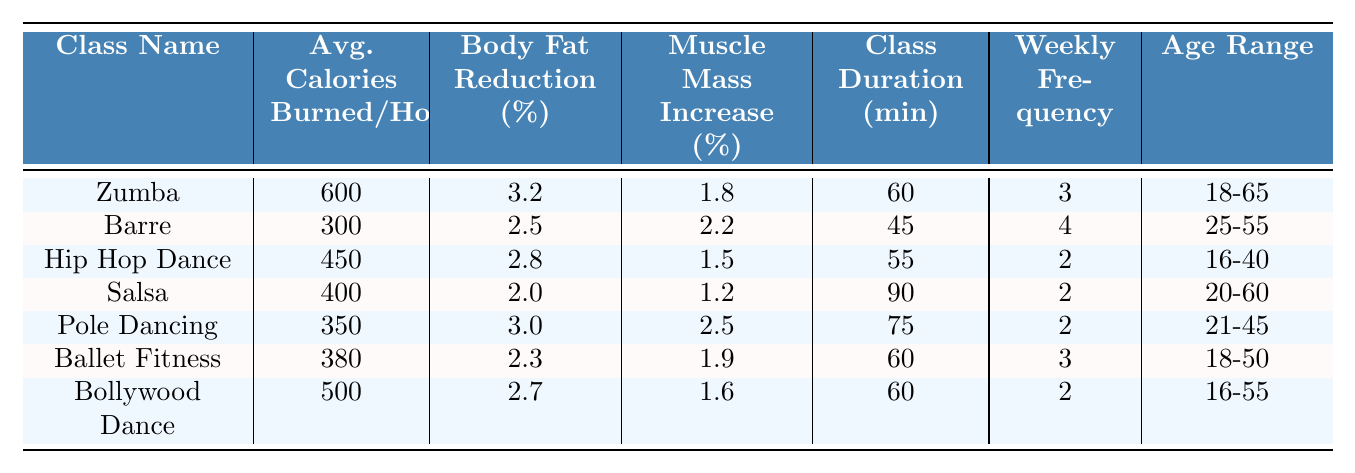What is the average number of calories burned per hour in Zumba classes? The table lists the average calories burned per hour for Zumba as 600.
Answer: 600 How many minutes does a Barre class typically last? The table shows that the class duration for Barre is 45 minutes.
Answer: 45 Which dance fitness class has the highest body fat reduction percentage? According to the table, Zumba has the highest body fat reduction percentage at 3.2%.
Answer: Zumba What is the weekly frequency of Ballet Fitness classes? The weekly frequency for Ballet Fitness is stated as 3 in the table.
Answer: 3 Which class has the least average calories burned per hour? By comparing the values in the table, Barre has the least calories burned per hour at 300.
Answer: Barre What is the difference in body fat reduction percentage between Zumba and Pole Dancing? Zumba has a body fat reduction percentage of 3.2% and Pole Dancing has 3.0%. The difference is 3.2 - 3.0 = 0.2.
Answer: 0.2 If someone attends Hip Hop Dance classes, how many calories would they burn in four classes? Hip Hop Dance burns 450 calories per hour and the class duration is 55 minutes. In four classes, they would burn approximately (450/60*55*4) = 990 calories.
Answer: 990 Is the average muscle mass increase percentage higher in Barre than in Ballet Fitness? Barre's muscle mass increase percentage is 2.2%, and Ballet Fitness is 1.9%. Since 2.2% is greater than 1.9%, the statement is true.
Answer: Yes How many total minutes would a participant spend in a week attending Salsa classes? Salsa classes last 90 minutes and are attended twice a week, so the total duration is 90 * 2 = 180 minutes.
Answer: 180 Which class has the highest muscle mass increase percentage and what is that percentage? The table indicates that Pole Dancing has the highest muscle mass increase percentage at 2.5%.
Answer: 2.5 If someone takes three Zumba classes and four Barre classes in one week, what’s the total duration spent in classes? Zumba lasts for 60 minutes and is taken 3 times (3*60=180 minutes), Barre lasts for 45 minutes and is taken 4 times (4*45=180 minutes). The total duration is 180 + 180 = 360 minutes.
Answer: 360 